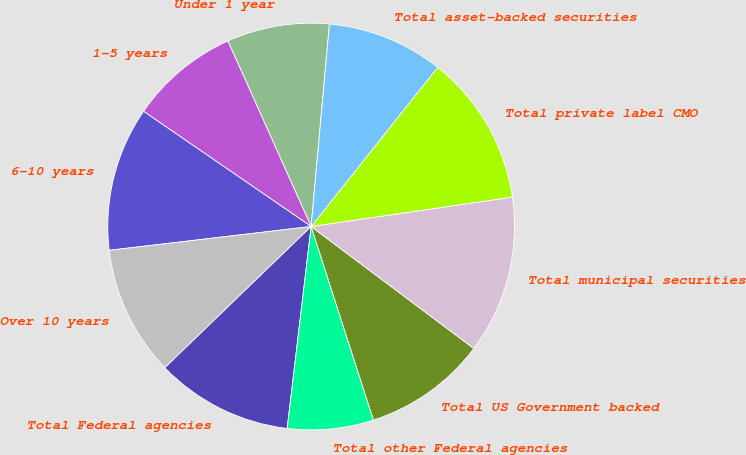Convert chart. <chart><loc_0><loc_0><loc_500><loc_500><pie_chart><fcel>Under 1 year<fcel>1-5 years<fcel>6-10 years<fcel>Over 10 years<fcel>Total Federal agencies<fcel>Total other Federal agencies<fcel>Total US Government backed<fcel>Total municipal securities<fcel>Total private label CMO<fcel>Total asset-backed securities<nl><fcel>8.15%<fcel>8.7%<fcel>11.45%<fcel>10.35%<fcel>10.9%<fcel>6.84%<fcel>9.8%<fcel>12.55%<fcel>12.0%<fcel>9.25%<nl></chart> 